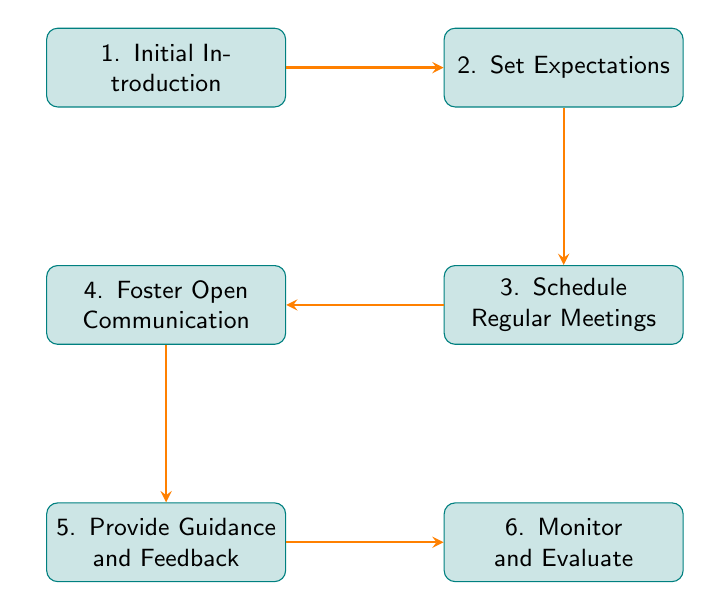What is the first step in the mentor-judge relationship building process? The first step is "Initial Introduction," which is the starting point of the mentorship process as depicted in the diagram.
Answer: Initial Introduction How many nodes are present in the flowchart? By counting the individual steps represented in the diagram, there are a total of six nodes.
Answer: 6 What step comes after "Set Expectations"? Following "Set Expectations," the next step is "Schedule Regular Meetings," which indicates the flow of the mentorship process.
Answer: Schedule Regular Meetings What is the last step in the diagram? The last step, which concludes the process, is "Monitor and Evaluate," serving as a review stage for the mentor-judge relationship.
Answer: Monitor and Evaluate What is the relationship between "Foster Open Communication" and "Provide Guidance and Feedback"? In the diagram, "Foster Open Communication" directly leads to "Provide Guidance and Feedback," indicating that open communication is essential for providing guidance.
Answer: Directly leads to Explain the flow of the first three steps. The flow begins with "Initial Introduction," followed by "Set Expectations," and then "Schedule Regular Meetings." This indicates that after the introduction, expectations are set before scheduling regular interactions.
Answer: Initial Introduction to Set Expectations to Schedule Regular Meetings How many arrows are in the diagram? Each connection between steps is represented by an arrow, and by counting them, there are five arrows present in the flowchart.
Answer: 5 What does the arrow from "Foster Open Communication" indicate? The arrow signifies a progression from "Foster Open Communication" to "Provide Guidance and Feedback," indicating that effective communication leads to constructive feedback.
Answer: Effective communication leads to feedback Which step is connected to "Provide Guidance and Feedback"? "Monitor and Evaluate" is the step that is connected to "Provide Guidance and Feedback," showing the importance of ongoing assessment after guidance is provided.
Answer: Monitor and Evaluate 